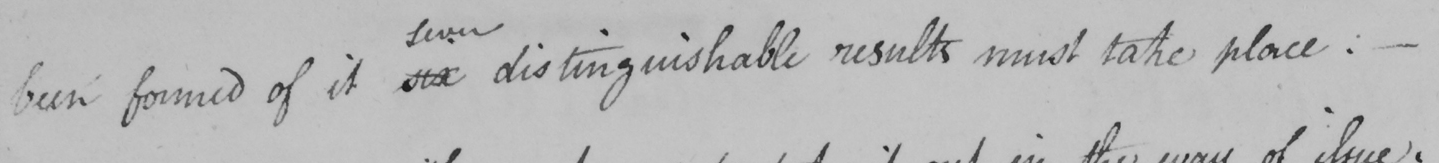Transcribe the text shown in this historical manuscript line. been formed of it six distinguishable results must take place :   _ 